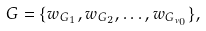<formula> <loc_0><loc_0><loc_500><loc_500>G = \{ w _ { G _ { 1 } } , w _ { G _ { 2 } } , \dots , w _ { G _ { \nu _ { 0 } } } \} ,</formula> 